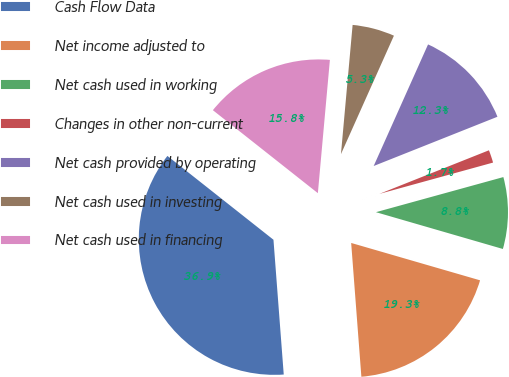Convert chart. <chart><loc_0><loc_0><loc_500><loc_500><pie_chart><fcel>Cash Flow Data<fcel>Net income adjusted to<fcel>Net cash used in working<fcel>Changes in other non-current<fcel>Net cash provided by operating<fcel>Net cash used in investing<fcel>Net cash used in financing<nl><fcel>36.86%<fcel>19.3%<fcel>8.77%<fcel>1.75%<fcel>12.28%<fcel>5.26%<fcel>15.79%<nl></chart> 